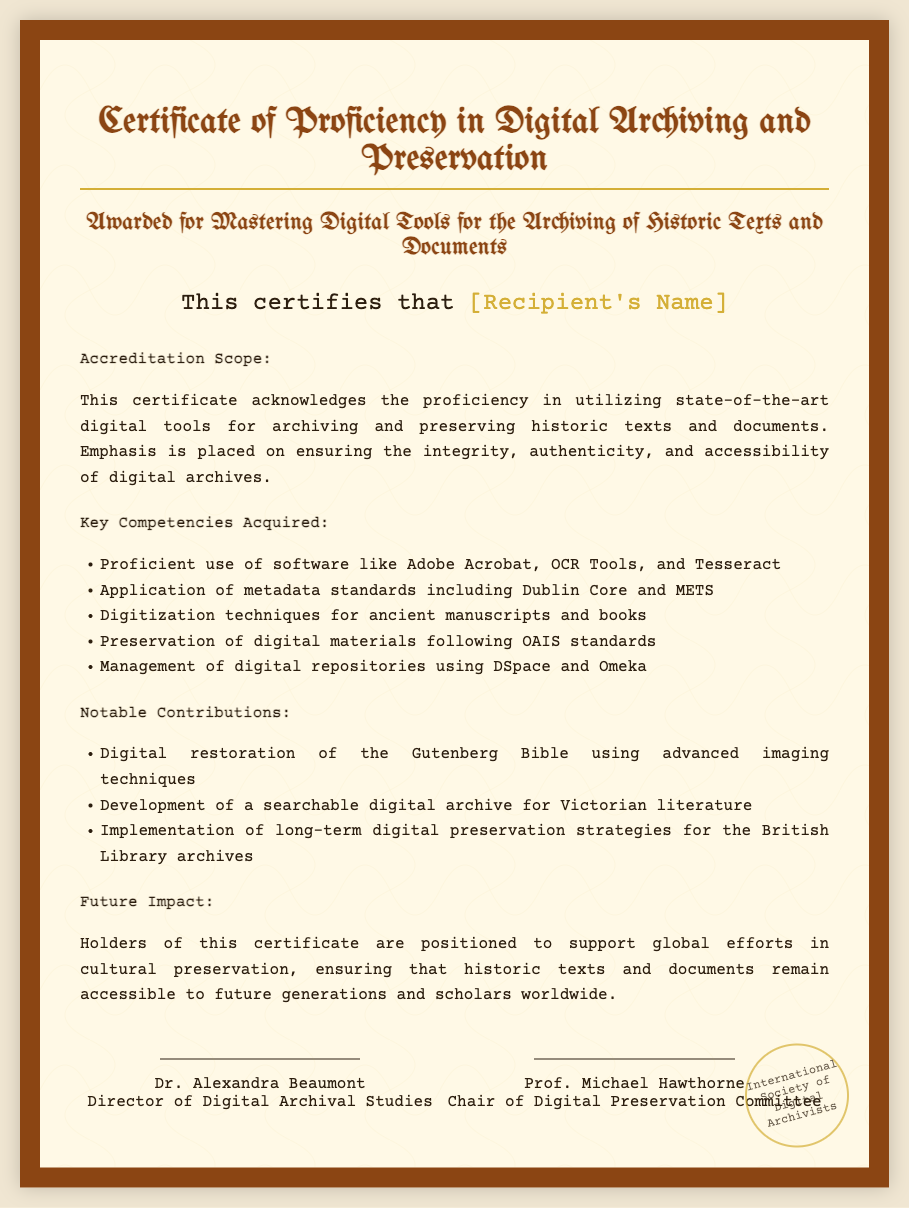What is the title of the certificate? The title is prominently displayed at the top of the certificate, indicating its purpose and recognition.
Answer: Certificate of Proficiency in Digital Archiving and Preservation Who is the recipient of the certificate? The recipient's name is highlighted in the certificate, representing the individual who achieved the proficiency.
Answer: [Recipient's Name] What software is mentioned for archiving? The document lists specific software utilized for archiving, showcasing the tools one should master.
Answer: Adobe Acrobat, OCR Tools, and Tesseract What standard is emphasized for digital preservation? The certificate mentions a specific standard that focuses on the management and preservation of digital archives.
Answer: OAIS standards Who signed the certificate? The document includes the names and titles of individuals who provided their endorsement and authority to the certificate.
Answer: Dr. Alexandra Beaumont and Prof. Michael Hawthorne What notable digital restoration is cited? The certificate highlights a significant project completed by the recipient, demonstrating their practical skills.
Answer: Digital restoration of the Gutenberg Bible What type of impact do holders of this certificate have? The certificate states the broader implications of obtaining this credential, indicating the contribution to societal needs.
Answer: Support global efforts in cultural preservation What is the issuing organization of the certificate? The stamp at the bottom of the certificate indicates the organization responsible for awarding this proficiency.
Answer: International Society of Digital Archivists 